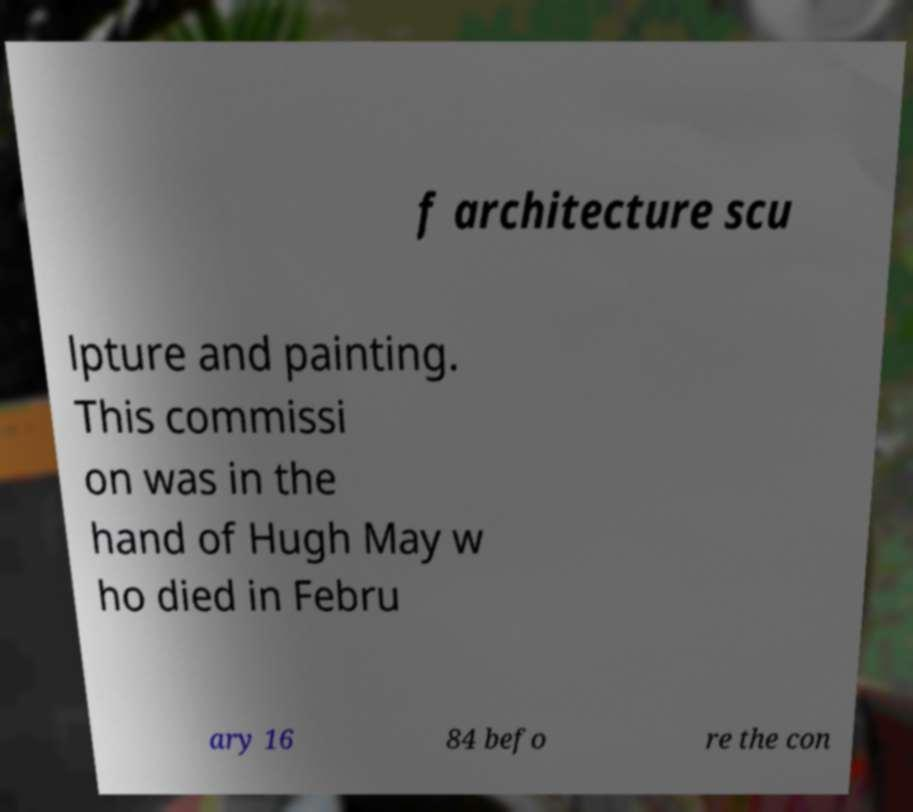Please read and relay the text visible in this image. What does it say? f architecture scu lpture and painting. This commissi on was in the hand of Hugh May w ho died in Febru ary 16 84 befo re the con 